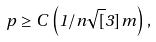Convert formula to latex. <formula><loc_0><loc_0><loc_500><loc_500>p \geq C \left ( 1 / n \sqrt { [ } 3 ] { m } \right ) ,</formula> 